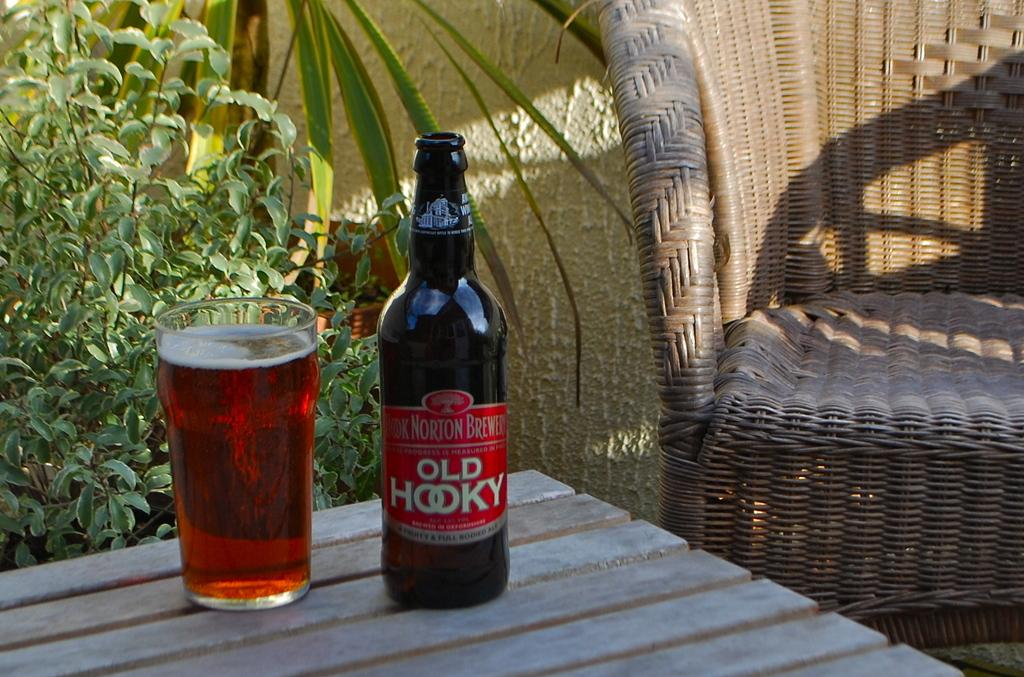<image>
Create a compact narrative representing the image presented. A bottle of Old Hooky is next to a full glass on a wooden table. 